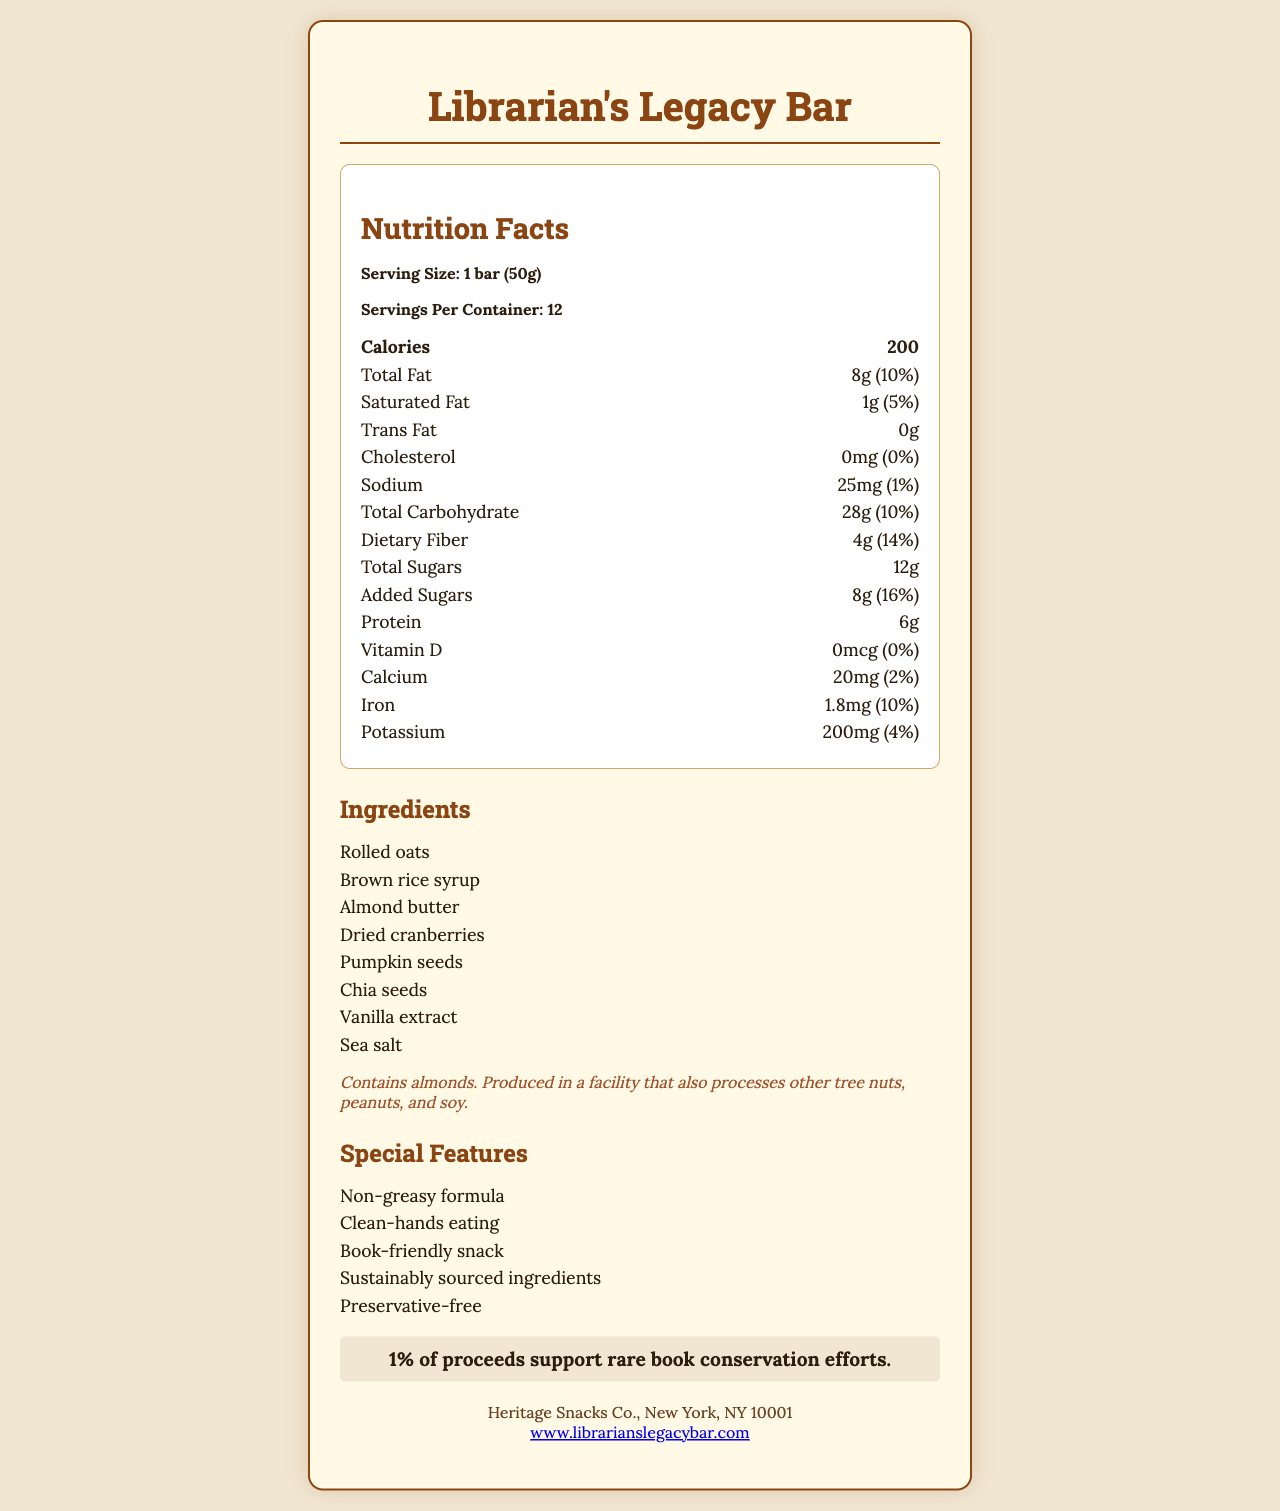who is the manufacturer of the Librarian's Legacy Bar? The document lists Heritage Snacks Co., New York, NY 10001 as the manufacturer.
Answer: Heritage Snacks Co., New York, NY 10001 how many servings are in one container? The document states that there are 12 servings per container.
Answer: 12 what is the total amount of dietary fiber in one serving? The document indicates that one serving of the Librarian's Legacy Bar contains 4g of dietary fiber.
Answer: 4g how many calories are there in a single bar? The nutrition facts section of the document states that a single bar contains 200 calories.
Answer: 200 list three main ingredients in the Librarian's Legacy Bar. The ingredients listed in the document include rolled oats, brown rice syrup, and almond butter among others.
Answer: Rolled oats, brown rice syrup, almond butter which nutrient has the highest daily value percentage per serving? A. Calcium B. Added Sugars C. Dietary Fiber Added Sugars have a daily value percentage of 16%, which is the highest among the listed nutrients.
Answer: B. Added Sugars what is the amount of protein in each bar? A. 4g B. 6g C. 8g D. 10g The document specifies that each bar contains 6g of protein.
Answer: B. 6g does the bar contain any preservatives? One of the special features listed is "Preservative-free", indicating that the bar does not contain any preservatives.
Answer: No are there any tree nuts in the ingredients? The allergen information specifies that the bar contains almonds, which are a type of tree nut.
Answer: Yes summarize the main features and purpose of the Librarian's Legacy Bar. This bar is designed to be both eco- and book-friendly, offering a convenient and clean-eating option, while also supporting a good cause related to rare book preservation.
Answer: The Librarian's Legacy Bar is an energy bar designed to be preservation-friendly, clean to handle, and book-friendly with ingredients that do not leave residues on hands. It contains non-greasy, sustainably sourced ingredients and is preservative-free. The bar supports conservation efforts by contributing 1% of proceeds to rare book conservation. It also has a balanced nutritional profile with significant protein, fiber, and vitamins. what are the benefits mentioned in the special features section? These are the benefits listed under the special features section in the document.
Answer: Non-greasy formula, clean-hands eating, book-friendly snack, sustainably sourced ingredients, preservative-free how much iron does each bar contain? The document states that each bar contains 1.8mg of iron.
Answer: 1.8mg can I determine if the bar is gluten-free from the document? The document does not provide information about gluten content or verify if the bar is gluten-free.
Answer: Not enough information what percentage of daily calcium does one bar provide? The nutrition facts section indicates that one bar provides 2% of the daily value of calcium.
Answer: 2% is the product safe for someone with a peanut allergy? The product is produced in a facility that also processes peanuts, which is mentioned in the allergen information.
Answer: No what is the serving size of the Librarian's Legacy Bar? The document specifies the serving size as 1 bar (50g).
Answer: 1 bar (50g) 